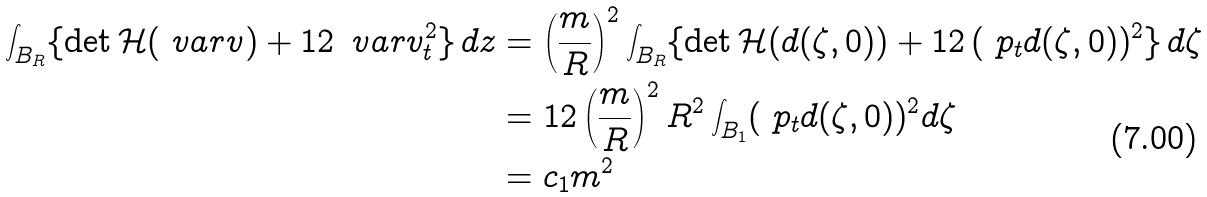<formula> <loc_0><loc_0><loc_500><loc_500>\int _ { B _ { R } } \{ \det \mathcal { H } ( \ v a r v ) + 1 2 \, \ v a r v _ { t } ^ { 2 } \} \, d z & = \left ( \frac { m } { R } \right ) ^ { 2 } \int _ { B _ { R } } \{ \det \mathcal { H } ( d ( \zeta , 0 ) ) + 1 2 \, ( \ p _ { t } d ( \zeta , 0 ) ) ^ { 2 } \} \, d \zeta \\ & = 1 2 \left ( \frac { m } { R } \right ) ^ { 2 } R ^ { 2 } \int _ { B _ { 1 } } ( \ p _ { t } d ( \zeta , 0 ) ) ^ { 2 } d \zeta \\ & = c _ { 1 } m ^ { 2 }</formula> 